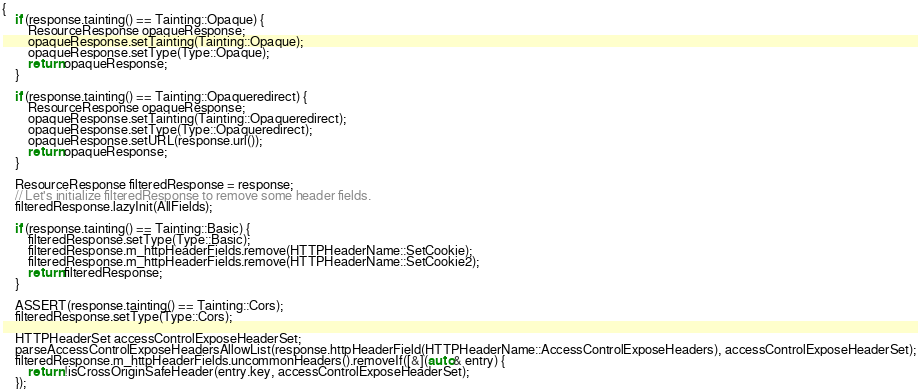Convert code to text. <code><loc_0><loc_0><loc_500><loc_500><_C++_>{
    if (response.tainting() == Tainting::Opaque) {
        ResourceResponse opaqueResponse;
        opaqueResponse.setTainting(Tainting::Opaque);
        opaqueResponse.setType(Type::Opaque);
        return opaqueResponse;
    }

    if (response.tainting() == Tainting::Opaqueredirect) {
        ResourceResponse opaqueResponse;
        opaqueResponse.setTainting(Tainting::Opaqueredirect);
        opaqueResponse.setType(Type::Opaqueredirect);
        opaqueResponse.setURL(response.url());
        return opaqueResponse;
    }

    ResourceResponse filteredResponse = response;
    // Let's initialize filteredResponse to remove some header fields.
    filteredResponse.lazyInit(AllFields);

    if (response.tainting() == Tainting::Basic) {
        filteredResponse.setType(Type::Basic);
        filteredResponse.m_httpHeaderFields.remove(HTTPHeaderName::SetCookie);
        filteredResponse.m_httpHeaderFields.remove(HTTPHeaderName::SetCookie2);
        return filteredResponse;
    }

    ASSERT(response.tainting() == Tainting::Cors);
    filteredResponse.setType(Type::Cors);

    HTTPHeaderSet accessControlExposeHeaderSet;
    parseAccessControlExposeHeadersAllowList(response.httpHeaderField(HTTPHeaderName::AccessControlExposeHeaders), accessControlExposeHeaderSet);
    filteredResponse.m_httpHeaderFields.uncommonHeaders().removeIf([&](auto& entry) {
        return !isCrossOriginSafeHeader(entry.key, accessControlExposeHeaderSet);
    });</code> 